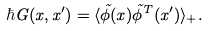Convert formula to latex. <formula><loc_0><loc_0><loc_500><loc_500>\hbar { G } ( x , x ^ { \prime } ) = \langle \tilde { \phi } ( x ) \tilde { \phi } ^ { T } ( x ^ { \prime } ) \rangle _ { + } .</formula> 